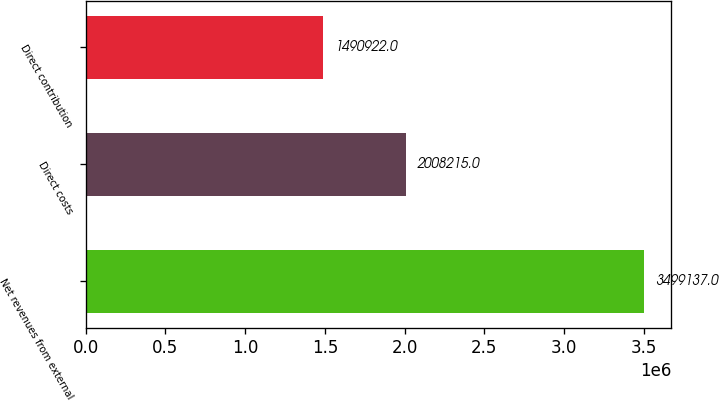<chart> <loc_0><loc_0><loc_500><loc_500><bar_chart><fcel>Net revenues from external<fcel>Direct costs<fcel>Direct contribution<nl><fcel>3.49914e+06<fcel>2.00822e+06<fcel>1.49092e+06<nl></chart> 